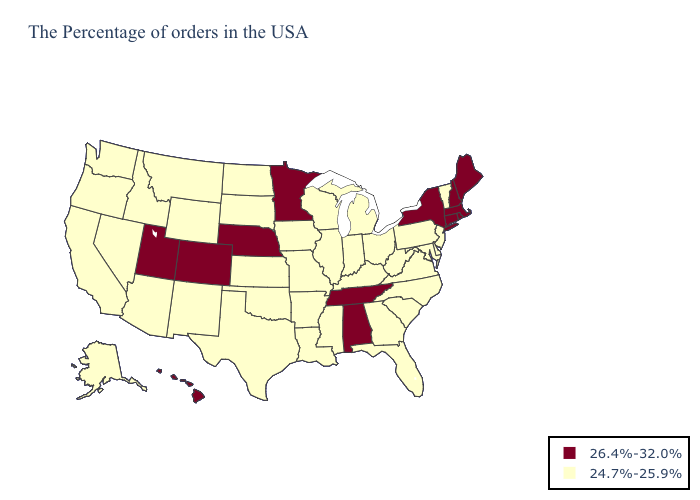What is the value of Mississippi?
Concise answer only. 24.7%-25.9%. Is the legend a continuous bar?
Answer briefly. No. Among the states that border Iowa , which have the highest value?
Give a very brief answer. Minnesota, Nebraska. Does Alabama have the lowest value in the South?
Short answer required. No. Is the legend a continuous bar?
Be succinct. No. What is the value of Arizona?
Keep it brief. 24.7%-25.9%. Does Nebraska have the lowest value in the MidWest?
Keep it brief. No. What is the highest value in states that border Florida?
Quick response, please. 26.4%-32.0%. Name the states that have a value in the range 26.4%-32.0%?
Write a very short answer. Maine, Massachusetts, Rhode Island, New Hampshire, Connecticut, New York, Alabama, Tennessee, Minnesota, Nebraska, Colorado, Utah, Hawaii. Among the states that border Utah , does Wyoming have the lowest value?
Quick response, please. Yes. What is the value of South Dakota?
Quick response, please. 24.7%-25.9%. Name the states that have a value in the range 26.4%-32.0%?
Give a very brief answer. Maine, Massachusetts, Rhode Island, New Hampshire, Connecticut, New York, Alabama, Tennessee, Minnesota, Nebraska, Colorado, Utah, Hawaii. Name the states that have a value in the range 24.7%-25.9%?
Concise answer only. Vermont, New Jersey, Delaware, Maryland, Pennsylvania, Virginia, North Carolina, South Carolina, West Virginia, Ohio, Florida, Georgia, Michigan, Kentucky, Indiana, Wisconsin, Illinois, Mississippi, Louisiana, Missouri, Arkansas, Iowa, Kansas, Oklahoma, Texas, South Dakota, North Dakota, Wyoming, New Mexico, Montana, Arizona, Idaho, Nevada, California, Washington, Oregon, Alaska. Name the states that have a value in the range 26.4%-32.0%?
Write a very short answer. Maine, Massachusetts, Rhode Island, New Hampshire, Connecticut, New York, Alabama, Tennessee, Minnesota, Nebraska, Colorado, Utah, Hawaii. Name the states that have a value in the range 26.4%-32.0%?
Write a very short answer. Maine, Massachusetts, Rhode Island, New Hampshire, Connecticut, New York, Alabama, Tennessee, Minnesota, Nebraska, Colorado, Utah, Hawaii. 